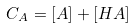<formula> <loc_0><loc_0><loc_500><loc_500>C _ { A } = [ A ] + [ H A ]</formula> 